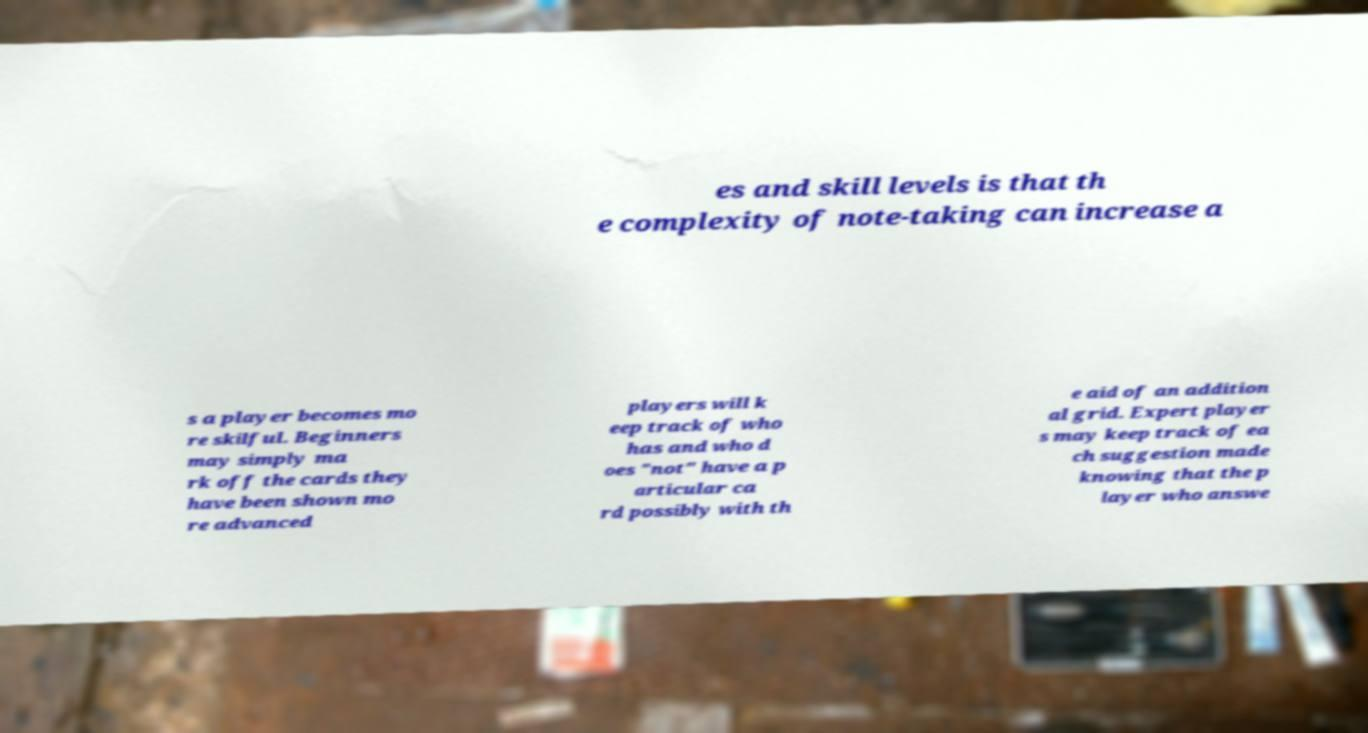Please read and relay the text visible in this image. What does it say? es and skill levels is that th e complexity of note-taking can increase a s a player becomes mo re skilful. Beginners may simply ma rk off the cards they have been shown mo re advanced players will k eep track of who has and who d oes "not" have a p articular ca rd possibly with th e aid of an addition al grid. Expert player s may keep track of ea ch suggestion made knowing that the p layer who answe 